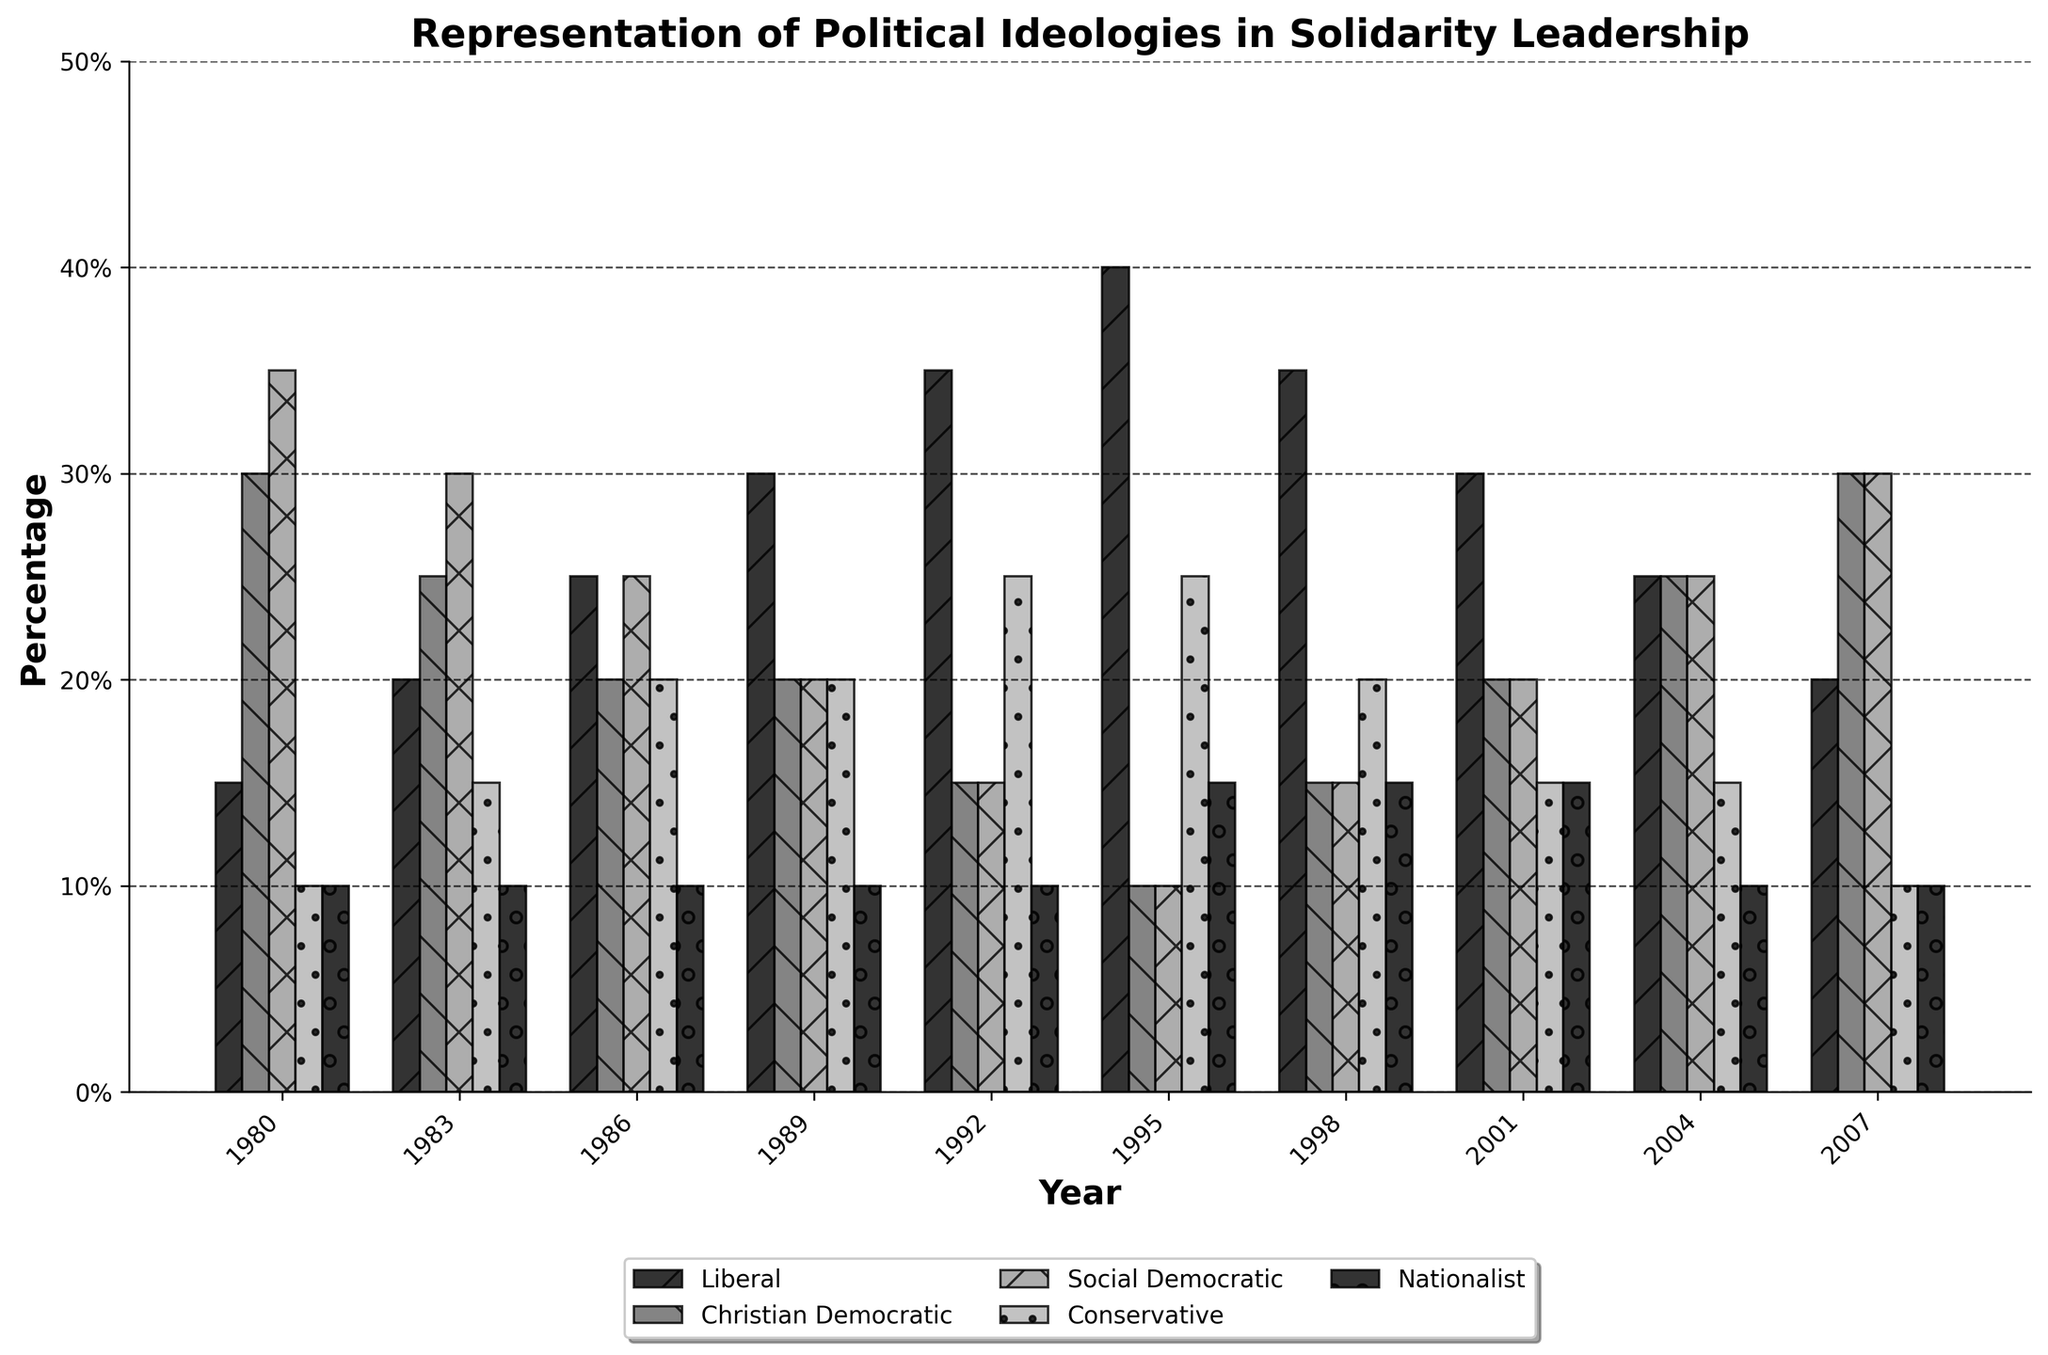Which ideology had the highest representation in 1980? The highest bar in the year 1980 represents the Social Democratic ideology at 35%.
Answer: Social Democratic What was the difference in representation between the Liberal and Nationalist ideologies in 1995? In 1995, the Liberal ideology had a representation of 40%, and the Nationalist ideology had 15%. The difference is calculated as 40% - 15% = 25%.
Answer: 25% How did the representation of the Conservative ideology change from 1980 to 2007? In 1980, the Conservative ideology had a representation of 10%, and in 2007, it also had 10%. The change is calculated as 10% - 10% = 0%.
Answer: No change Which year had the highest combined representation of Social Democratic and Christian Democratic ideologies? To find the year with the highest combined representation, sum the values for Social Democratic and Christian Democratic for each year. The maximum combined value is in 2007, where Social Democratic is 30% and Christian Democratic is 30%, summing to 60%.
Answer: 2007 What was the average representation of the Liberal ideology over the entire period? Sum the percentages of the Liberal ideology over all years (15+20+25+30+35+40+35+30+25+20) and divide by the number of years (10): (275/10)=27.5%.
Answer: 27.5% Compare the representation trends of the Christian Democratic and Liberal ideologies between 1980 and 2004. Which had a more consistent increase or decrease? The Liberal ideology shows a general increasing trend from 15% in 1980 to 25% in 2004, with some fluctuations. Christian Democratic, meanwhile, decreases overall from 30% in 1980 to 25% in 2004 but with more fluctuations in between. Liberal had a more consistent increase.
Answer: Liberal How did the representation of the Nationalist and Conservative ideologies change from 1989 to 1998? In 1989, Nationalist had 10% and Conservative had 20%. In 1998, Nationalist had 15% and Conservative had 20%. Hence, Nationalist increased by 5% while Conservative remained the same.
Answer: Nationalist increased, Conservative same Was there any year where no ideology had representation higher than 35%? Yes, in 1980, the highest representation for any ideology was the Social Democratic at 35%. Every other ideology had lower than 35%.
Answer: 1980 Calculate the percentage difference in Social Democratic representation between 1983 and 1986. The representation in 1983 is 30% and in 1986 is 25%. The percentage difference is calculated as (30% - 25%) / 30% * 100% = 16.67%.
Answer: 16.67% 